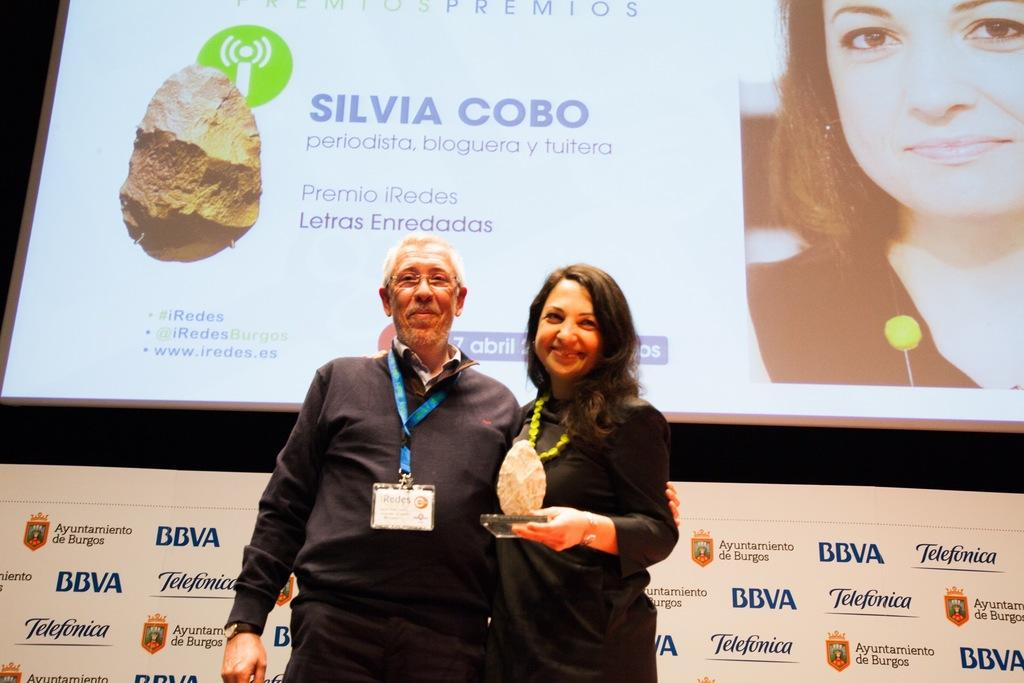What is happening in the image? There are people standing in the image. What can be observed about the people in the image? The people are wearing ID cards. Can you describe the woman's actions in the image? A woman is holding a stone trophy in her hand. What can be seen in the background of the image? There are banners visible in the background of the image. What type of invention can be seen in the hands of the people in the image? There is no invention visible in the hands of the people in the image. What kind of toys are being played with by the people in the image? There are no toys present in the image. 